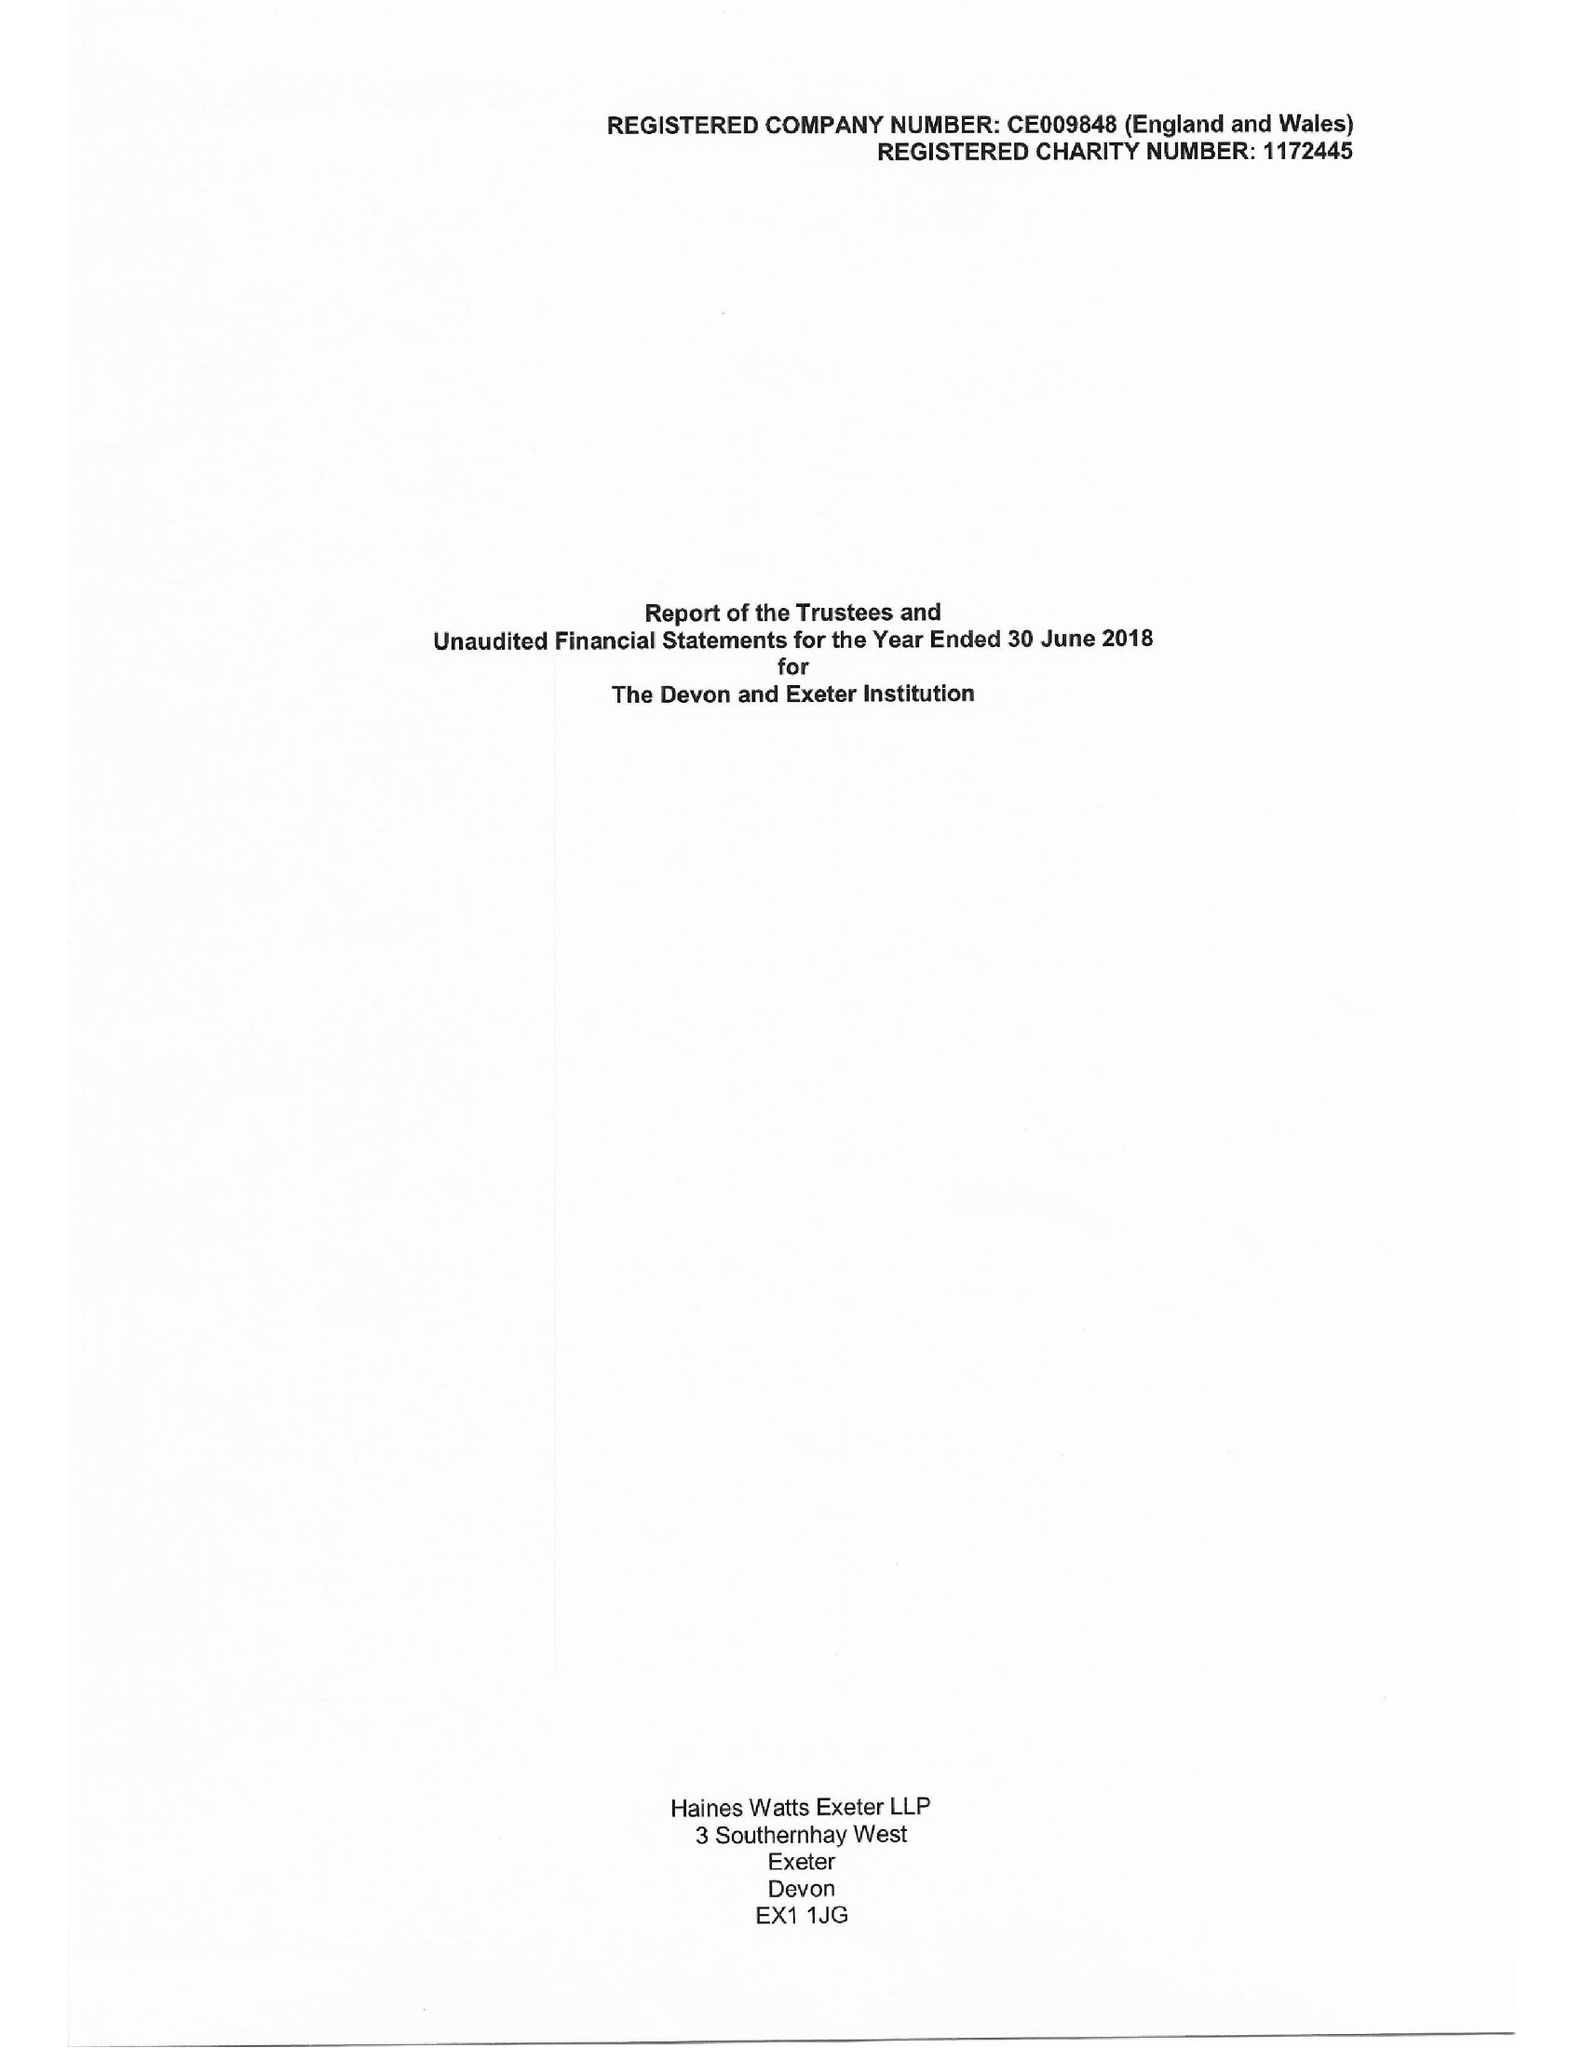What is the value for the address__post_town?
Answer the question using a single word or phrase. EXETER 